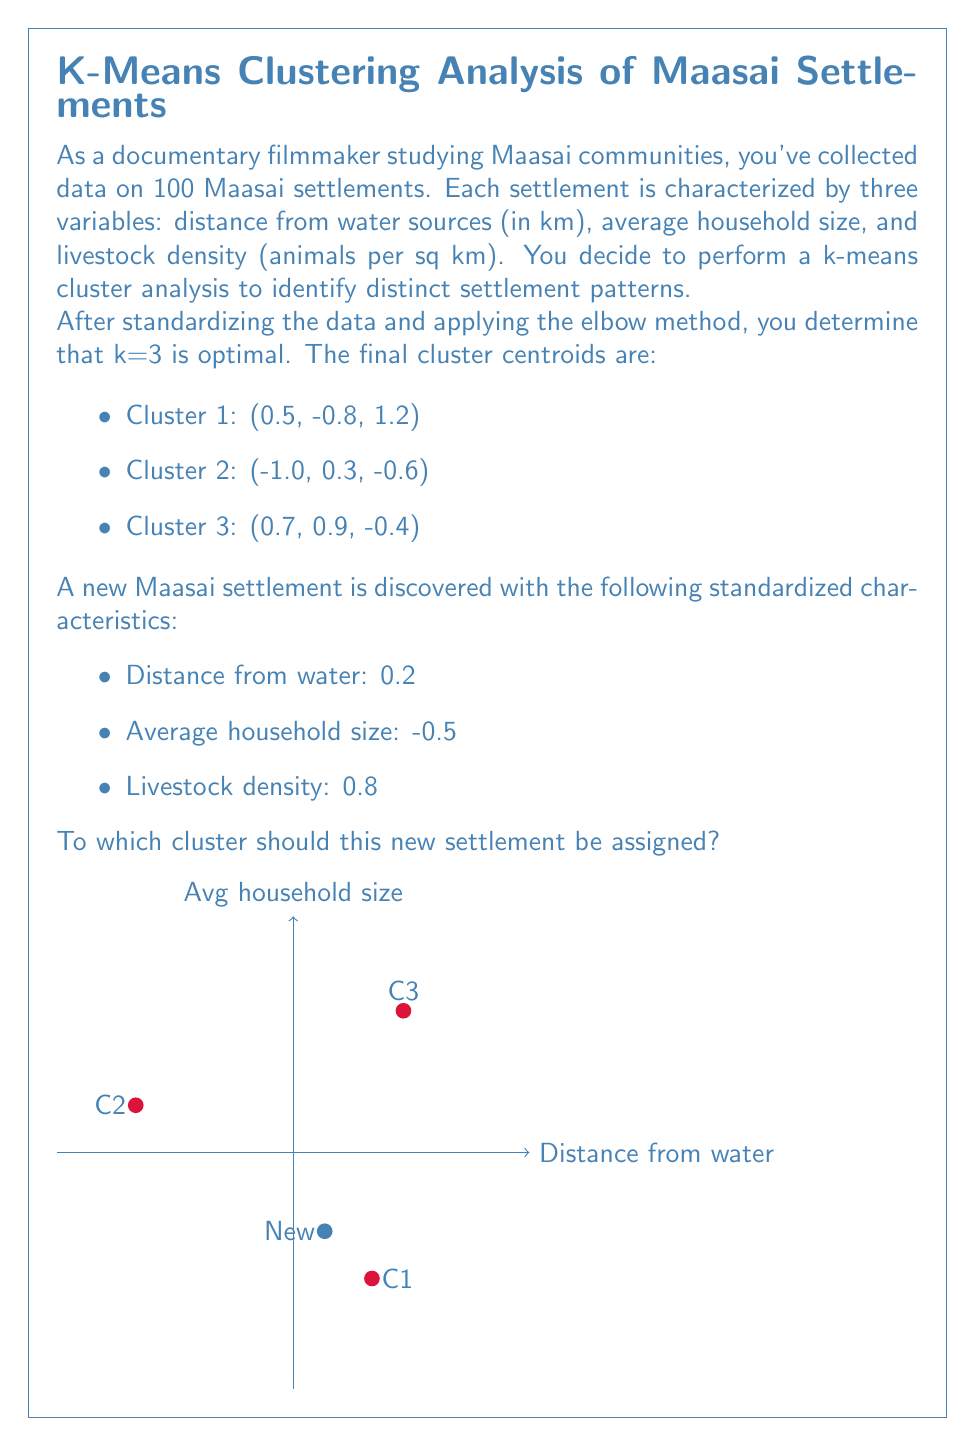What is the answer to this math problem? To determine which cluster the new settlement should be assigned to, we need to calculate the Euclidean distance between the new point and each cluster centroid, then assign it to the nearest cluster.

Step 1: Calculate the Euclidean distance between the new point and each cluster centroid.

The Euclidean distance in 3D space is given by:
$$d = \sqrt{(x_2-x_1)^2 + (y_2-y_1)^2 + (z_2-z_1)^2}$$

For Cluster 1:
$$d_1 = \sqrt{(0.2-0.5)^2 + (-0.5+0.8)^2 + (0.8-1.2)^2}$$
$$d_1 = \sqrt{0.09 + 0.09 + 0.16} = \sqrt{0.34} \approx 0.5831$$

For Cluster 2:
$$d_2 = \sqrt{(0.2+1.0)^2 + (-0.5-0.3)^2 + (0.8+0.6)^2}$$
$$d_2 = \sqrt{1.44 + 0.64 + 1.96} = \sqrt{4.04} \approx 2.0100$$

For Cluster 3:
$$d_3 = \sqrt{(0.2-0.7)^2 + (-0.5-0.9)^2 + (0.8+0.4)^2}$$
$$d_3 = \sqrt{0.25 + 1.96 + 1.44} = \sqrt{3.65} \approx 1.9105$$

Step 2: Compare the distances and assign the new point to the cluster with the smallest distance.

The smallest distance is $d_1 \approx 0.5831$, corresponding to Cluster 1.

Therefore, the new settlement should be assigned to Cluster 1.
Answer: Cluster 1 